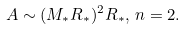Convert formula to latex. <formula><loc_0><loc_0><loc_500><loc_500>A \sim ( M _ { * } R _ { * } ) ^ { 2 } R _ { * } , \, n = 2 .</formula> 